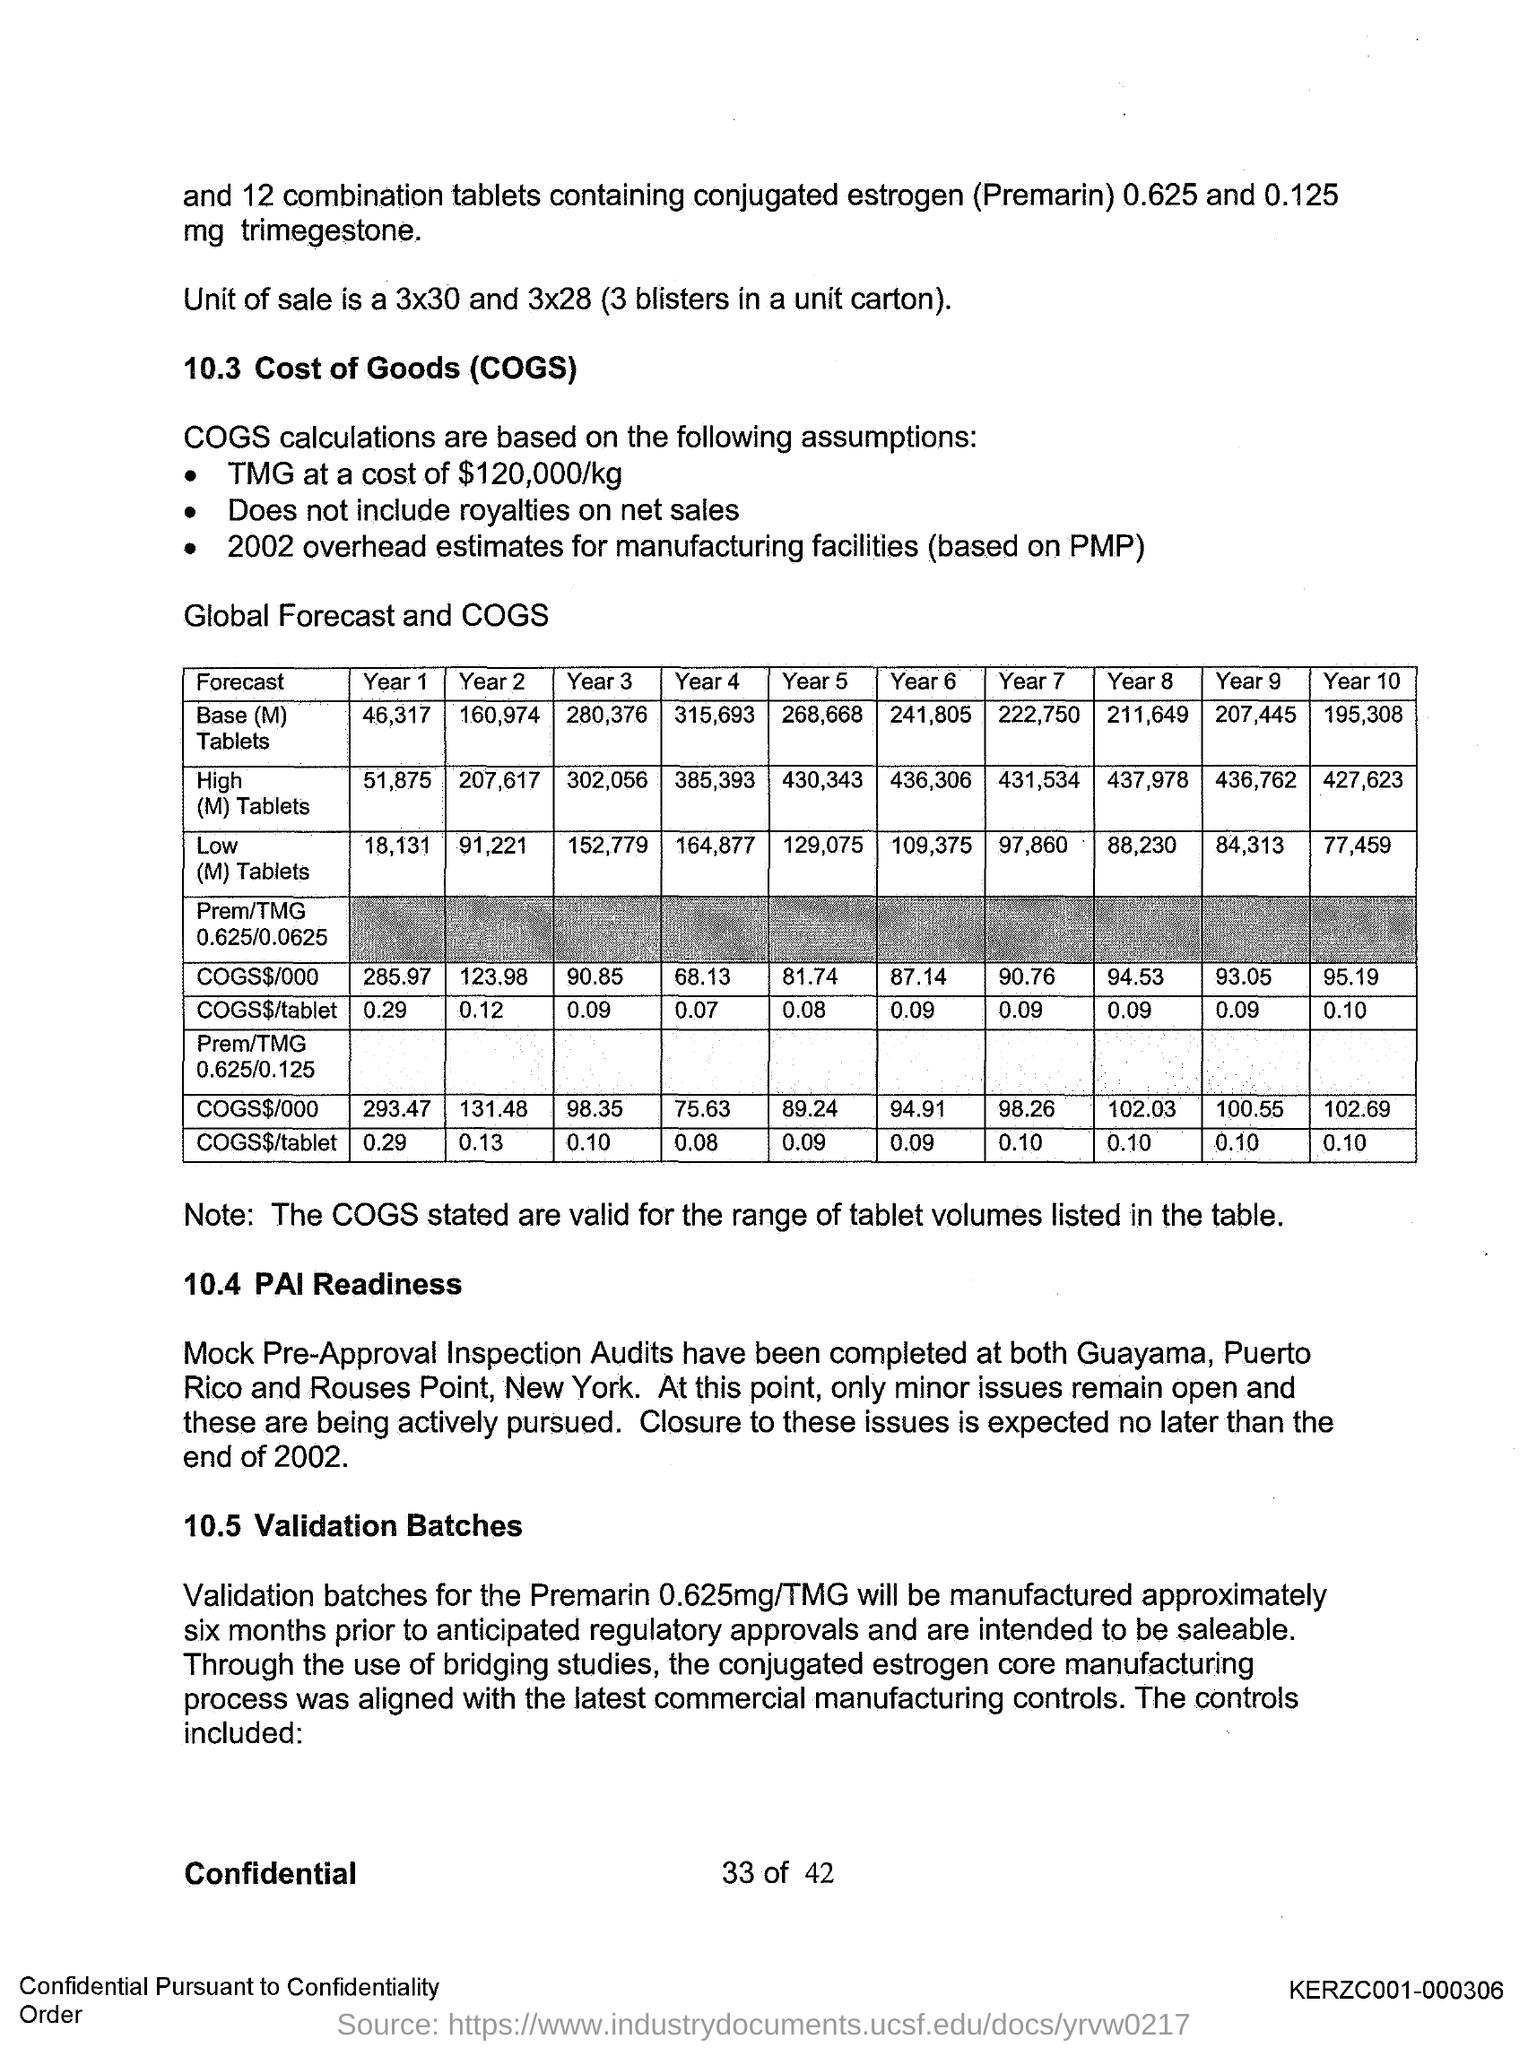What is the full form of COGS?
Your answer should be compact. Cost of Goods. What is the full form of PAI?
Make the answer very short. Pre-Approval Inspection. 